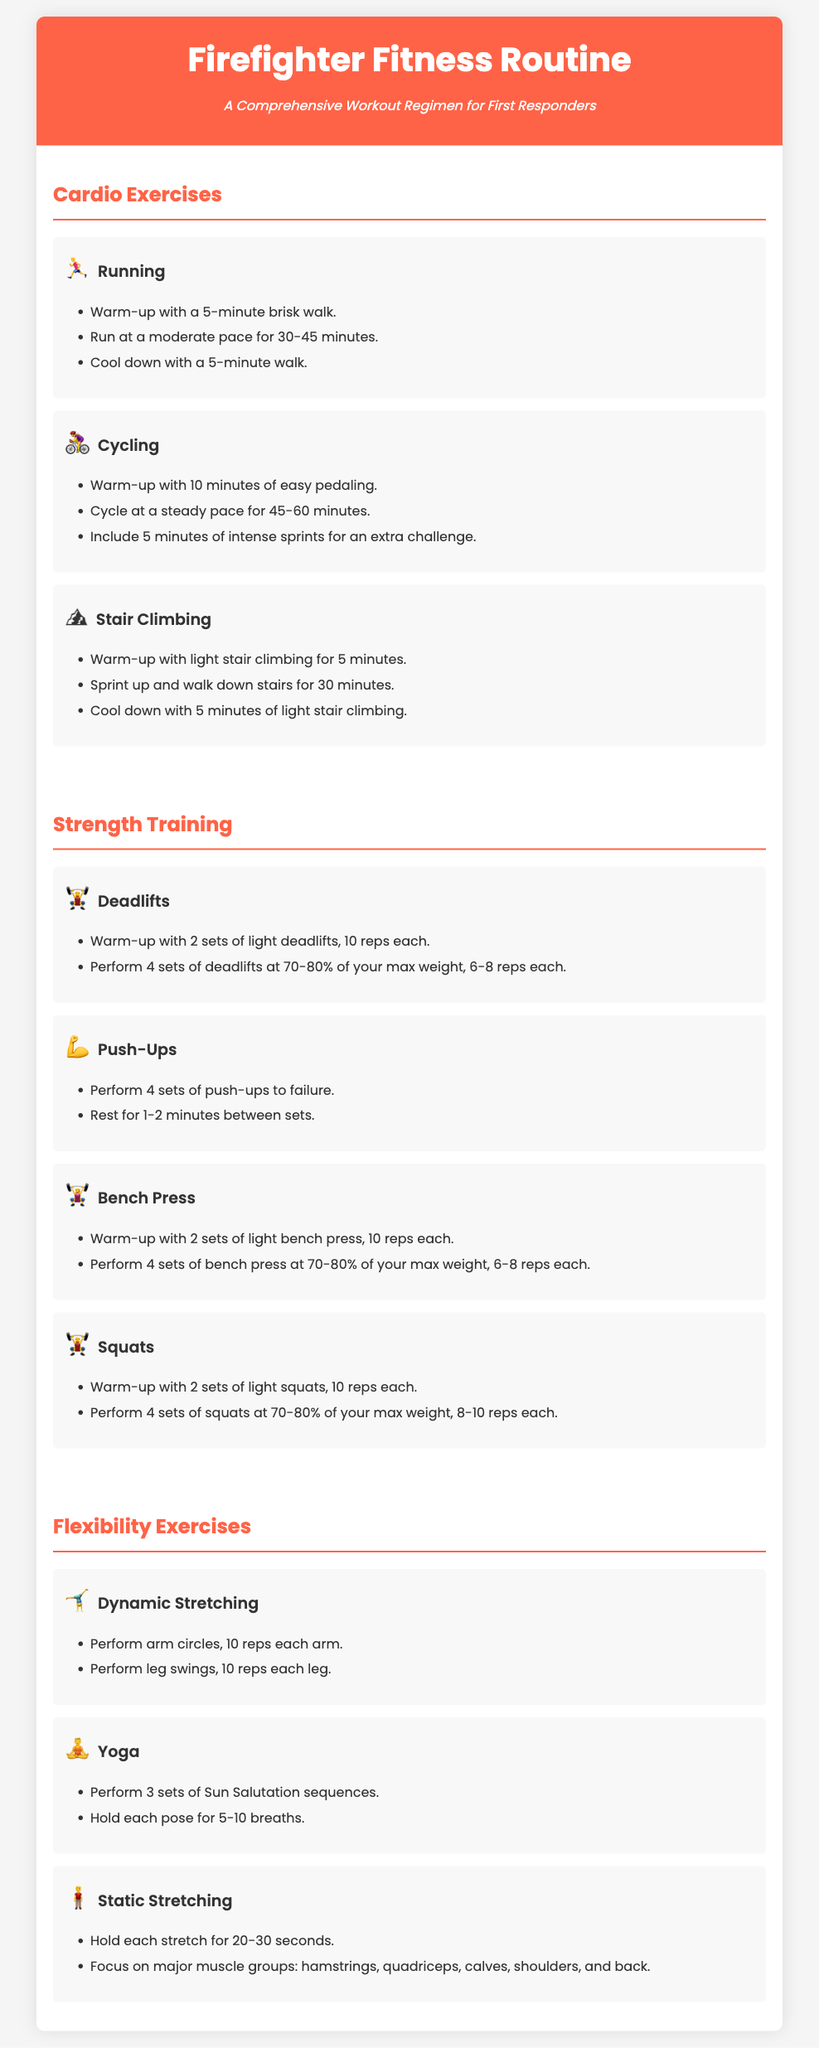what is the title of the document? The title is prominently displayed in the header section of the document.
Answer: Firefighter Fitness Routine how many cardio exercises are listed? The document lists a total of three cardio exercises in the corresponding section.
Answer: 3 what is the first strength training exercise mentioned? The first strength training exercise is specifically stated at the beginning of the Strength Training section.
Answer: Deadlifts how many sets are recommended for push-ups? The document specifies the number of sets as part of the workout regimen.
Answer: 4 what icon represents cycling? The icon used to represent cycling is shown next to the exercise title.
Answer: 🚴‍♀️ what is the duration for stair climbing? The duration for the stair climbing exercise is mentioned in the instructions for that exercise.
Answer: 30 minutes how many repetitions are suggested for static stretching? The number of seconds to hold each stretch is indicated within the flexibility exercises section.
Answer: 20-30 seconds what type of stretching is included in the flexibility exercises? The document outlines different types of stretching exercises under the flexibility section.
Answer: Dynamic Stretching what percentage of max weight should deadlifts be performed at? The recommended percentage of max weight for deadlifts is detailed in the strength training description.
Answer: 70-80% 